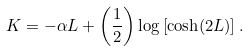Convert formula to latex. <formula><loc_0><loc_0><loc_500><loc_500>K = - \alpha L + \left ( \frac { 1 } { 2 } \right ) \log \left [ \cosh ( 2 L ) \right ] .</formula> 